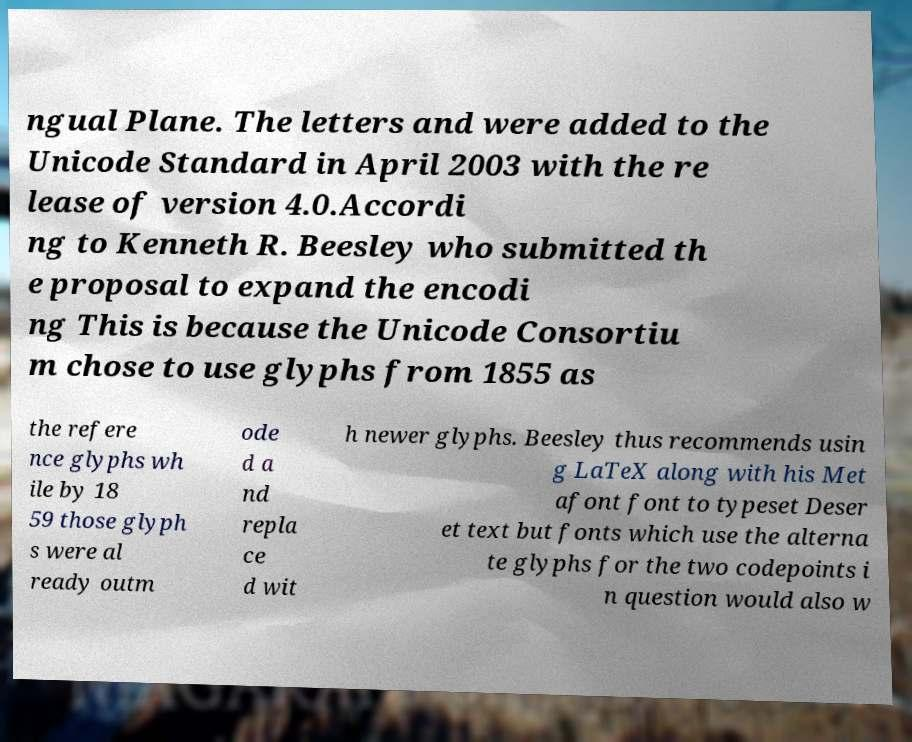Can you read and provide the text displayed in the image?This photo seems to have some interesting text. Can you extract and type it out for me? ngual Plane. The letters and were added to the Unicode Standard in April 2003 with the re lease of version 4.0.Accordi ng to Kenneth R. Beesley who submitted th e proposal to expand the encodi ng This is because the Unicode Consortiu m chose to use glyphs from 1855 as the refere nce glyphs wh ile by 18 59 those glyph s were al ready outm ode d a nd repla ce d wit h newer glyphs. Beesley thus recommends usin g LaTeX along with his Met afont font to typeset Deser et text but fonts which use the alterna te glyphs for the two codepoints i n question would also w 